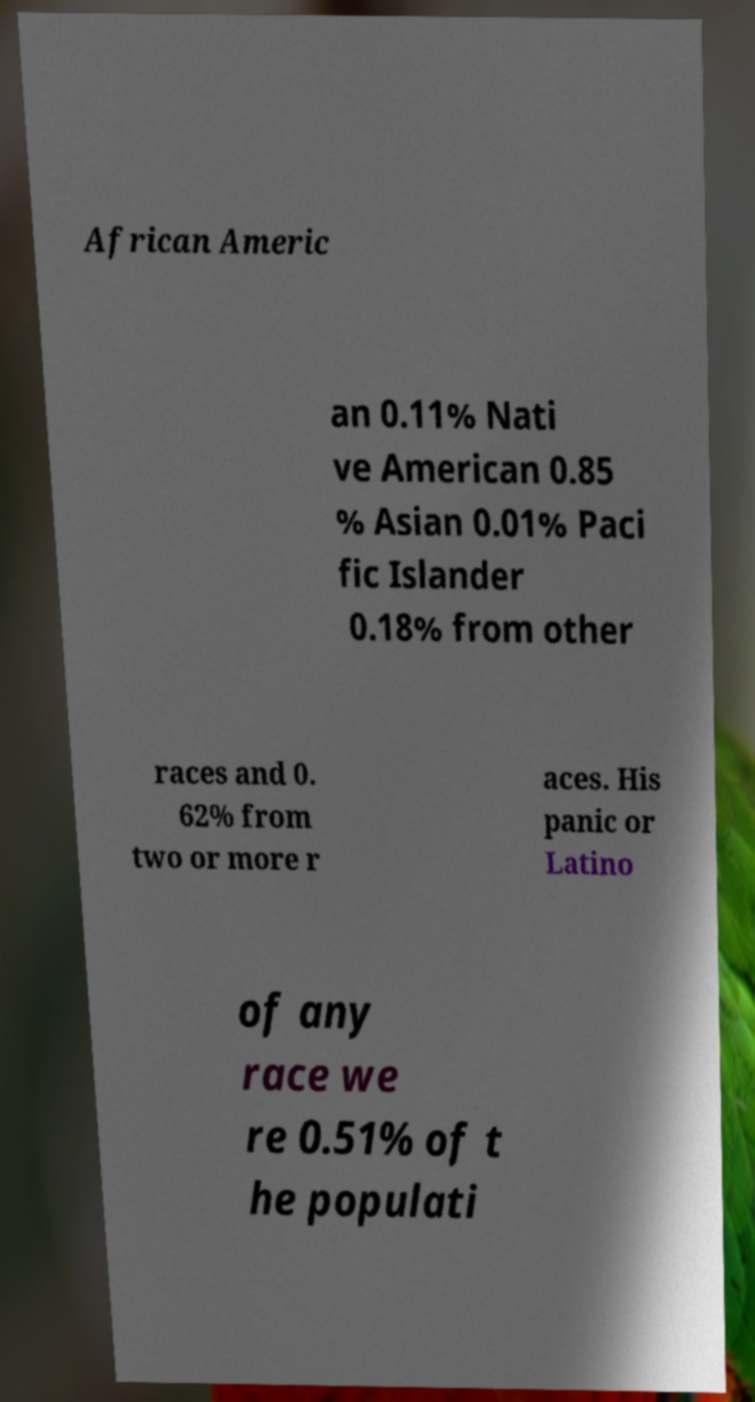Please identify and transcribe the text found in this image. African Americ an 0.11% Nati ve American 0.85 % Asian 0.01% Paci fic Islander 0.18% from other races and 0. 62% from two or more r aces. His panic or Latino of any race we re 0.51% of t he populati 